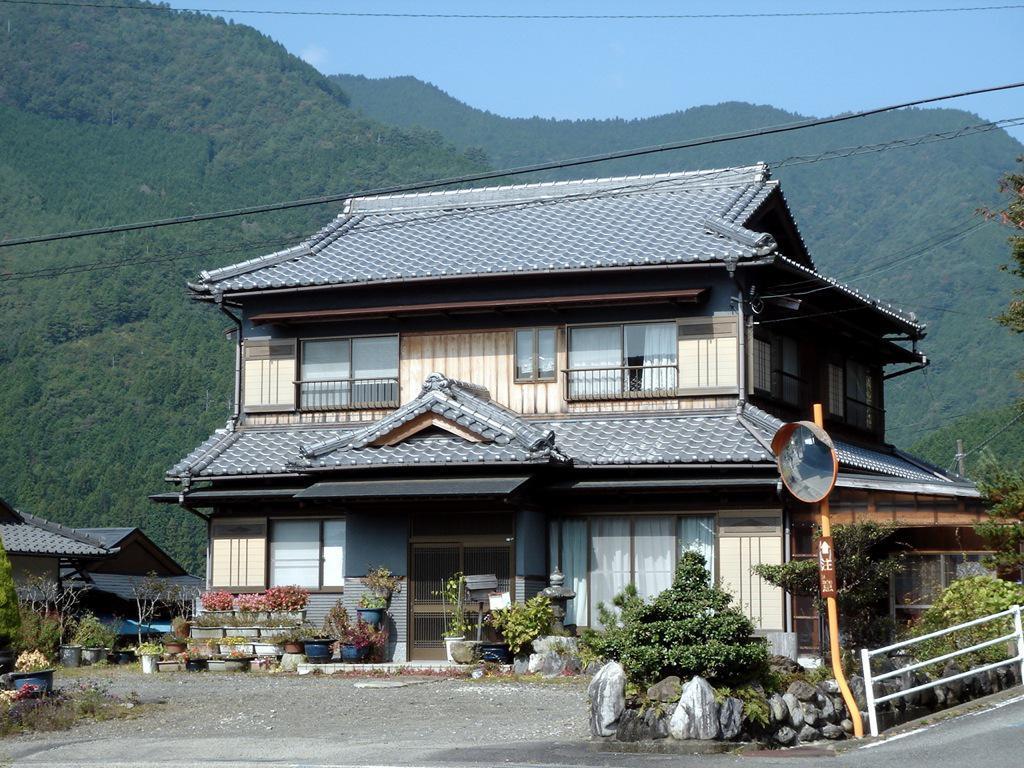Describe this image in one or two sentences. In this picture we can see few houses, in front of the house we can find few plants, rocks, metal rods and a convex mirror, in the background we can see hills and trees. 